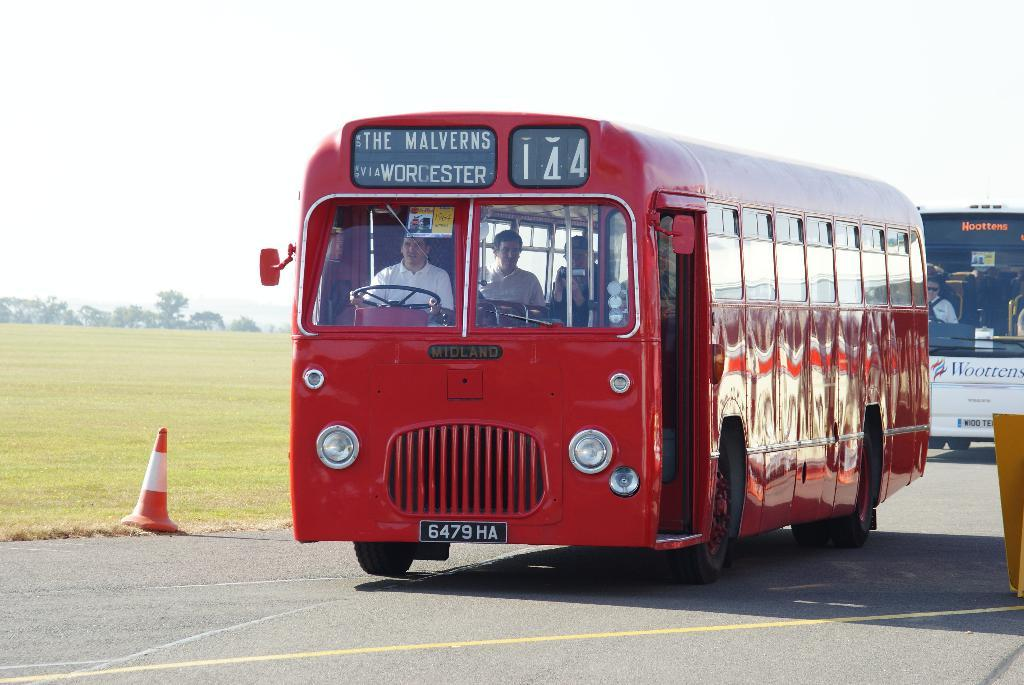<image>
Create a compact narrative representing the image presented. A red double decker bus with route number 144 is driving along the road. 